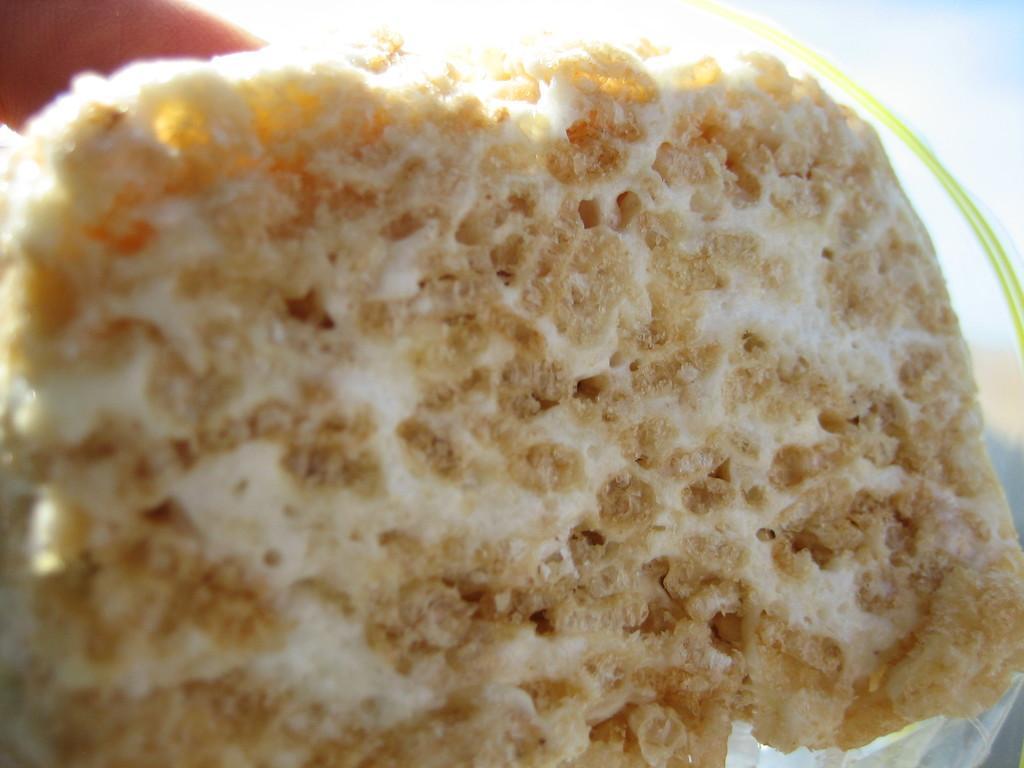Please provide a concise description of this image. In this image we can see a food item. In the background it is blur. 